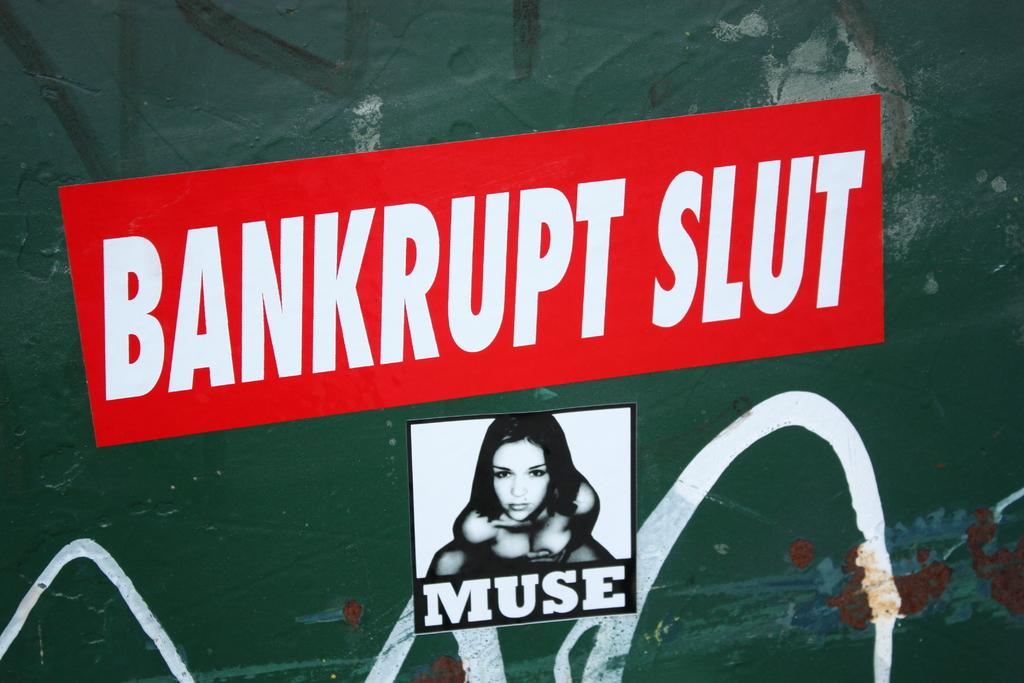<image>
Render a clear and concise summary of the photo. Wall poster graffetti in green background with bankrupt slut sticker in white lettering and neon red background and MUSE sticker underneath. 